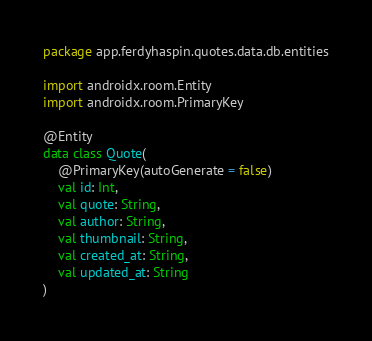<code> <loc_0><loc_0><loc_500><loc_500><_Kotlin_>package app.ferdyhaspin.quotes.data.db.entities

import androidx.room.Entity
import androidx.room.PrimaryKey

@Entity
data class Quote(
    @PrimaryKey(autoGenerate = false)
    val id: Int,
    val quote: String,
    val author: String,
    val thumbnail: String,
    val created_at: String,
    val updated_at: String
)</code> 